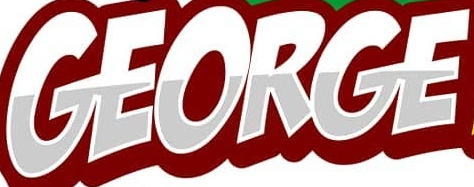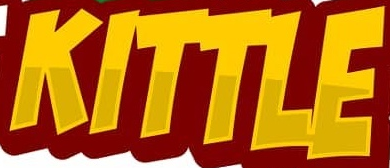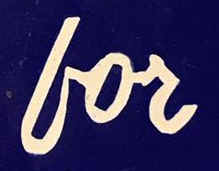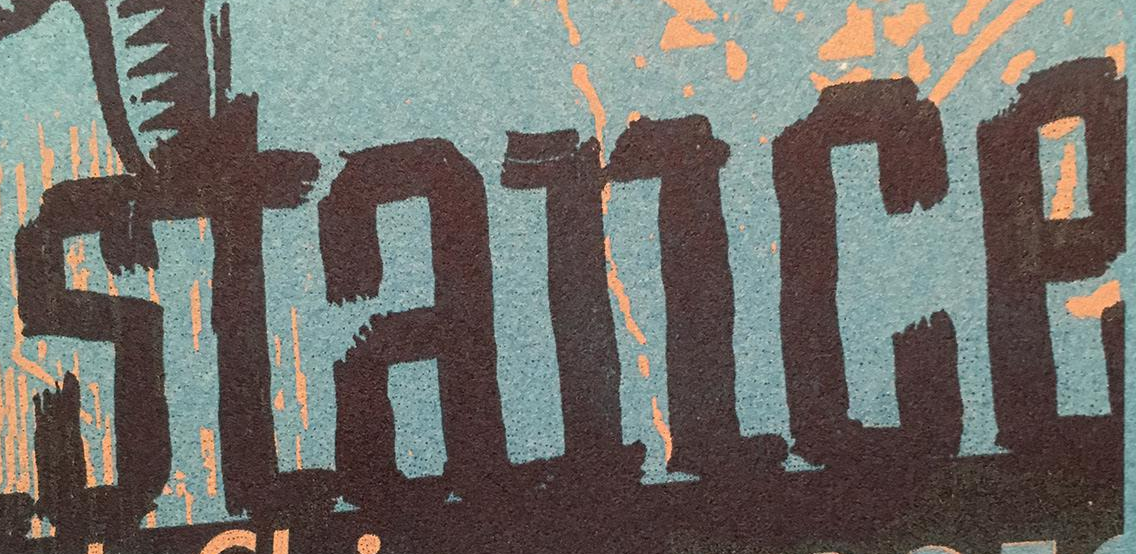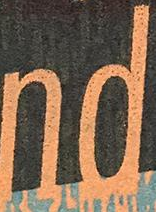Identify the words shown in these images in order, separated by a semicolon. GEORGE; KITTLE; for; stance; nd 